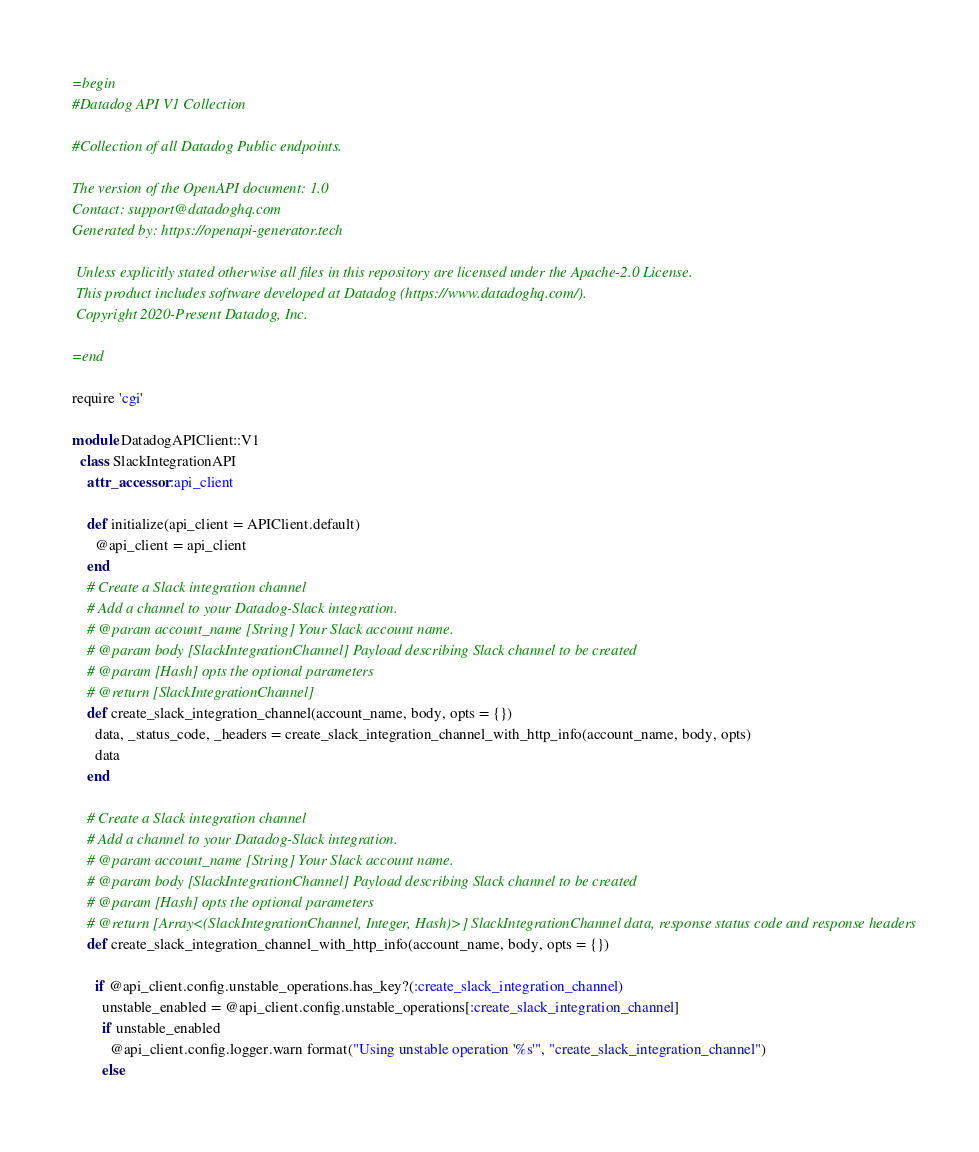Convert code to text. <code><loc_0><loc_0><loc_500><loc_500><_Ruby_>=begin
#Datadog API V1 Collection

#Collection of all Datadog Public endpoints.

The version of the OpenAPI document: 1.0
Contact: support@datadoghq.com
Generated by: https://openapi-generator.tech

 Unless explicitly stated otherwise all files in this repository are licensed under the Apache-2.0 License.
 This product includes software developed at Datadog (https://www.datadoghq.com/).
 Copyright 2020-Present Datadog, Inc.

=end

require 'cgi'

module DatadogAPIClient::V1
  class SlackIntegrationAPI
    attr_accessor :api_client

    def initialize(api_client = APIClient.default)
      @api_client = api_client
    end
    # Create a Slack integration channel
    # Add a channel to your Datadog-Slack integration.
    # @param account_name [String] Your Slack account name.
    # @param body [SlackIntegrationChannel] Payload describing Slack channel to be created
    # @param [Hash] opts the optional parameters
    # @return [SlackIntegrationChannel]
    def create_slack_integration_channel(account_name, body, opts = {})
      data, _status_code, _headers = create_slack_integration_channel_with_http_info(account_name, body, opts)
      data
    end

    # Create a Slack integration channel
    # Add a channel to your Datadog-Slack integration.
    # @param account_name [String] Your Slack account name.
    # @param body [SlackIntegrationChannel] Payload describing Slack channel to be created
    # @param [Hash] opts the optional parameters
    # @return [Array<(SlackIntegrationChannel, Integer, Hash)>] SlackIntegrationChannel data, response status code and response headers
    def create_slack_integration_channel_with_http_info(account_name, body, opts = {})

      if @api_client.config.unstable_operations.has_key?(:create_slack_integration_channel)
        unstable_enabled = @api_client.config.unstable_operations[:create_slack_integration_channel]
        if unstable_enabled
          @api_client.config.logger.warn format("Using unstable operation '%s'", "create_slack_integration_channel")
        else</code> 